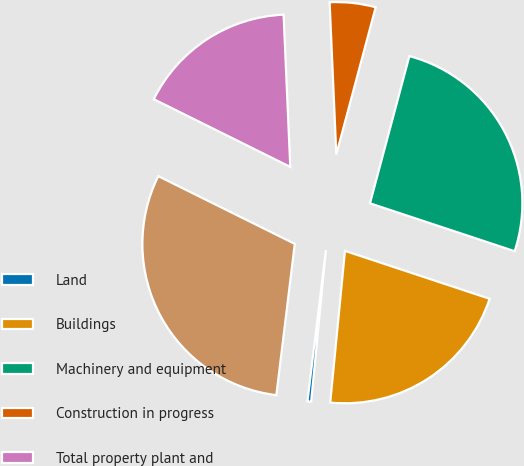Convert chart. <chart><loc_0><loc_0><loc_500><loc_500><pie_chart><fcel>Land<fcel>Buildings<fcel>Machinery and equipment<fcel>Construction in progress<fcel>Total property plant and<fcel>Less accumulated depreciation<nl><fcel>0.39%<fcel>21.45%<fcel>25.93%<fcel>4.86%<fcel>16.97%<fcel>30.4%<nl></chart> 